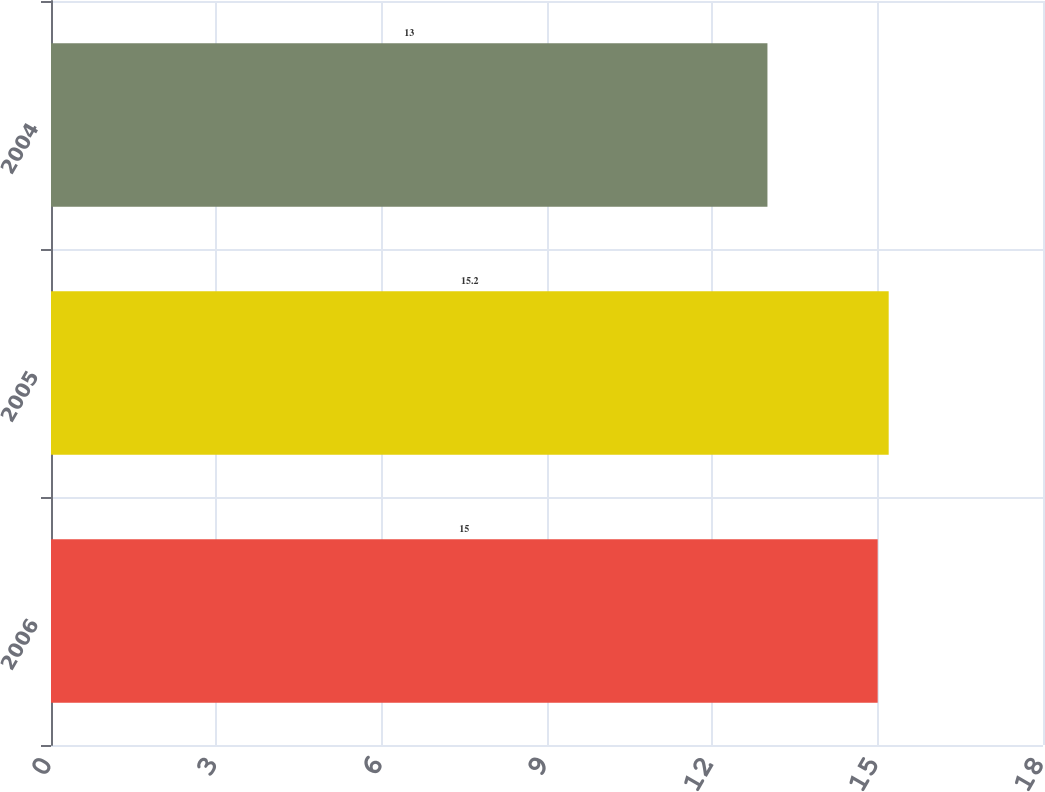Convert chart to OTSL. <chart><loc_0><loc_0><loc_500><loc_500><bar_chart><fcel>2006<fcel>2005<fcel>2004<nl><fcel>15<fcel>15.2<fcel>13<nl></chart> 